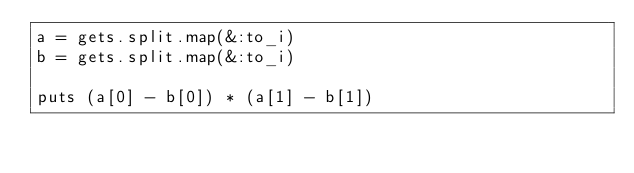Convert code to text. <code><loc_0><loc_0><loc_500><loc_500><_Ruby_>a = gets.split.map(&:to_i)
b = gets.split.map(&:to_i)

puts (a[0] - b[0]) * (a[1] - b[1])</code> 